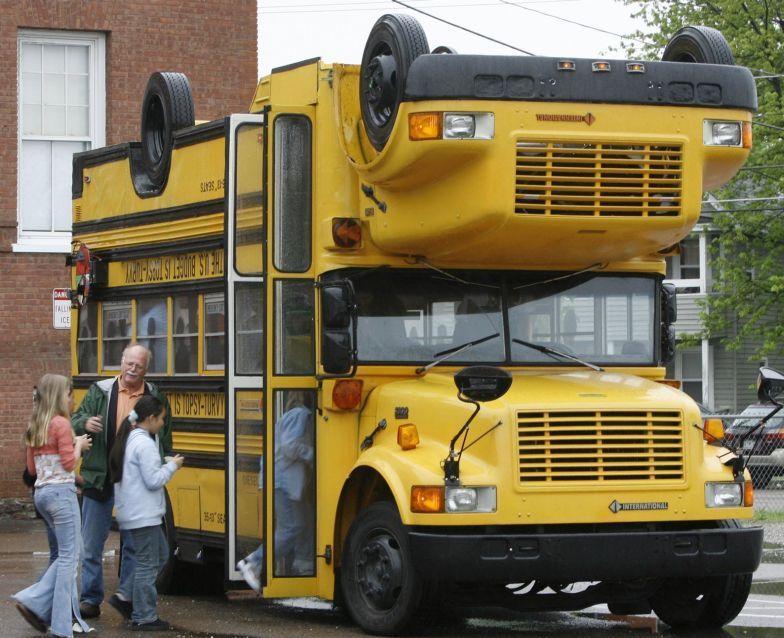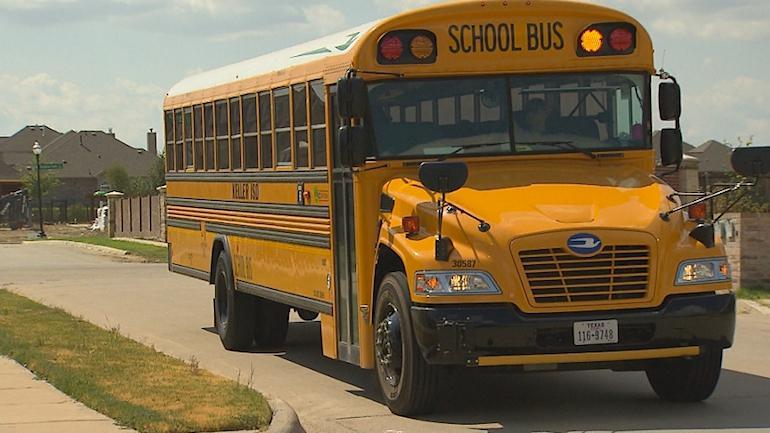The first image is the image on the left, the second image is the image on the right. Examine the images to the left and right. Is the description "The right image shows a leftward-angled non-flat bus, and the left image shows the front of a parked non-flat bus that has only one hood and grille and has a license plate on its front bumper." accurate? Answer yes or no. No. The first image is the image on the left, the second image is the image on the right. Analyze the images presented: Is the assertion "In one of the images, the bus passenger door is open." valid? Answer yes or no. Yes. 